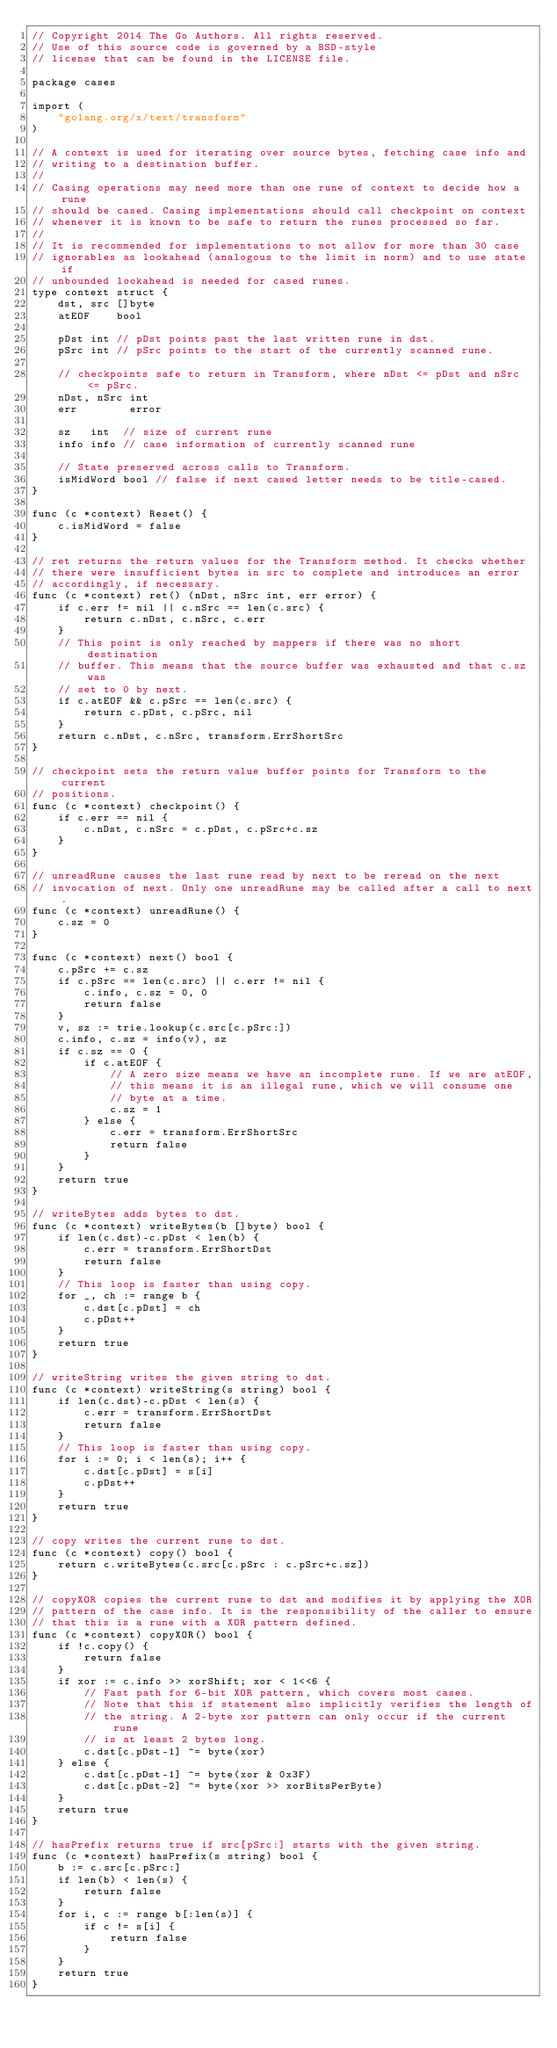Convert code to text. <code><loc_0><loc_0><loc_500><loc_500><_Go_>// Copyright 2014 The Go Authors. All rights reserved.
// Use of this source code is governed by a BSD-style
// license that can be found in the LICENSE file.

package cases

import (
	"golang.org/x/text/transform"
)

// A context is used for iterating over source bytes, fetching case info and
// writing to a destination buffer.
//
// Casing operations may need more than one rune of context to decide how a rune
// should be cased. Casing implementations should call checkpoint on context
// whenever it is known to be safe to return the runes processed so far.
//
// It is recommended for implementations to not allow for more than 30 case
// ignorables as lookahead (analogous to the limit in norm) and to use state if
// unbounded lookahead is needed for cased runes.
type context struct {
	dst, src []byte
	atEOF    bool

	pDst int // pDst points past the last written rune in dst.
	pSrc int // pSrc points to the start of the currently scanned rune.

	// checkpoints safe to return in Transform, where nDst <= pDst and nSrc <= pSrc.
	nDst, nSrc int
	err        error

	sz   int  // size of current rune
	info info // case information of currently scanned rune

	// State preserved across calls to Transform.
	isMidWord bool // false if next cased letter needs to be title-cased.
}

func (c *context) Reset() {
	c.isMidWord = false
}

// ret returns the return values for the Transform method. It checks whether
// there were insufficient bytes in src to complete and introduces an error
// accordingly, if necessary.
func (c *context) ret() (nDst, nSrc int, err error) {
	if c.err != nil || c.nSrc == len(c.src) {
		return c.nDst, c.nSrc, c.err
	}
	// This point is only reached by mappers if there was no short destination
	// buffer. This means that the source buffer was exhausted and that c.sz was
	// set to 0 by next.
	if c.atEOF && c.pSrc == len(c.src) {
		return c.pDst, c.pSrc, nil
	}
	return c.nDst, c.nSrc, transform.ErrShortSrc
}

// checkpoint sets the return value buffer points for Transform to the current
// positions.
func (c *context) checkpoint() {
	if c.err == nil {
		c.nDst, c.nSrc = c.pDst, c.pSrc+c.sz
	}
}

// unreadRune causes the last rune read by next to be reread on the next
// invocation of next. Only one unreadRune may be called after a call to next.
func (c *context) unreadRune() {
	c.sz = 0
}

func (c *context) next() bool {
	c.pSrc += c.sz
	if c.pSrc == len(c.src) || c.err != nil {
		c.info, c.sz = 0, 0
		return false
	}
	v, sz := trie.lookup(c.src[c.pSrc:])
	c.info, c.sz = info(v), sz
	if c.sz == 0 {
		if c.atEOF {
			// A zero size means we have an incomplete rune. If we are atEOF,
			// this means it is an illegal rune, which we will consume one
			// byte at a time.
			c.sz = 1
		} else {
			c.err = transform.ErrShortSrc
			return false
		}
	}
	return true
}

// writeBytes adds bytes to dst.
func (c *context) writeBytes(b []byte) bool {
	if len(c.dst)-c.pDst < len(b) {
		c.err = transform.ErrShortDst
		return false
	}
	// This loop is faster than using copy.
	for _, ch := range b {
		c.dst[c.pDst] = ch
		c.pDst++
	}
	return true
}

// writeString writes the given string to dst.
func (c *context) writeString(s string) bool {
	if len(c.dst)-c.pDst < len(s) {
		c.err = transform.ErrShortDst
		return false
	}
	// This loop is faster than using copy.
	for i := 0; i < len(s); i++ {
		c.dst[c.pDst] = s[i]
		c.pDst++
	}
	return true
}

// copy writes the current rune to dst.
func (c *context) copy() bool {
	return c.writeBytes(c.src[c.pSrc : c.pSrc+c.sz])
}

// copyXOR copies the current rune to dst and modifies it by applying the XOR
// pattern of the case info. It is the responsibility of the caller to ensure
// that this is a rune with a XOR pattern defined.
func (c *context) copyXOR() bool {
	if !c.copy() {
		return false
	}
	if xor := c.info >> xorShift; xor < 1<<6 {
		// Fast path for 6-bit XOR pattern, which covers most cases.
		// Note that this if statement also implicitly verifies the length of
		// the string. A 2-byte xor pattern can only occur if the current rune
		// is at least 2 bytes long.
		c.dst[c.pDst-1] ^= byte(xor)
	} else {
		c.dst[c.pDst-1] ^= byte(xor & 0x3F)
		c.dst[c.pDst-2] ^= byte(xor >> xorBitsPerByte)
	}
	return true
}

// hasPrefix returns true if src[pSrc:] starts with the given string.
func (c *context) hasPrefix(s string) bool {
	b := c.src[c.pSrc:]
	if len(b) < len(s) {
		return false
	}
	for i, c := range b[:len(s)] {
		if c != s[i] {
			return false
		}
	}
	return true
}
</code> 